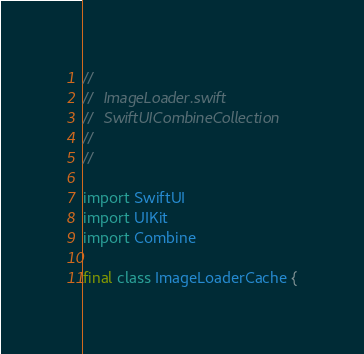Convert code to text. <code><loc_0><loc_0><loc_500><loc_500><_Swift_>//
//  ImageLoader.swift
//  SwiftUICombineCollection
//
//

import SwiftUI
import UIKit
import Combine

final class ImageLoaderCache {</code> 